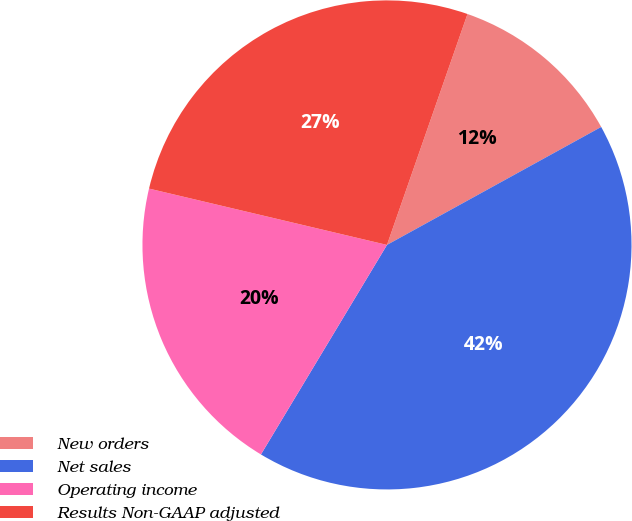Convert chart to OTSL. <chart><loc_0><loc_0><loc_500><loc_500><pie_chart><fcel>New orders<fcel>Net sales<fcel>Operating income<fcel>Results Non-GAAP adjusted<nl><fcel>11.65%<fcel>41.63%<fcel>20.08%<fcel>26.64%<nl></chart> 